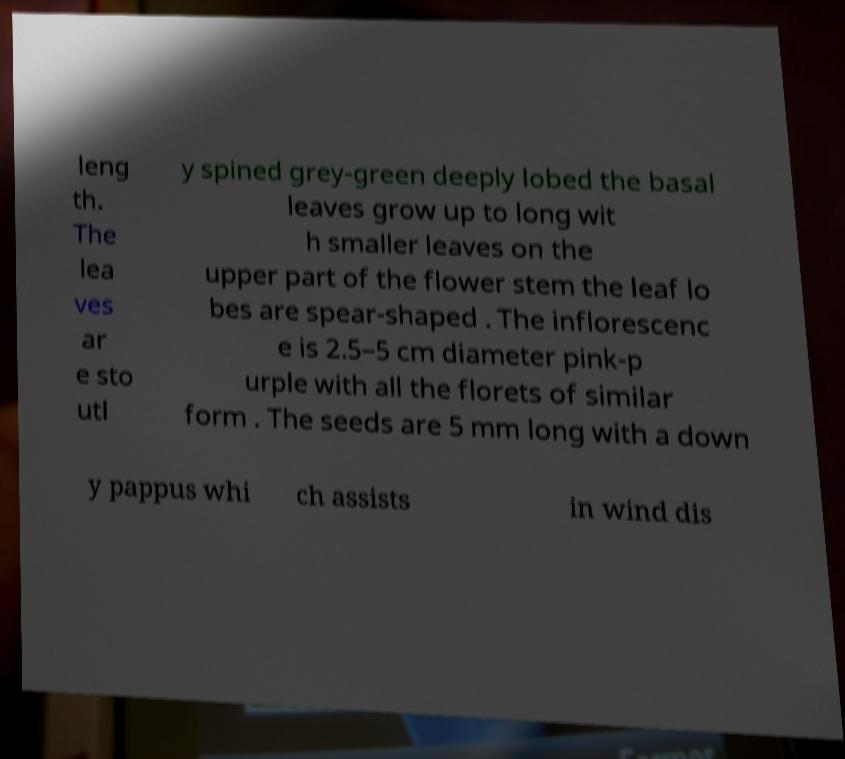There's text embedded in this image that I need extracted. Can you transcribe it verbatim? leng th. The lea ves ar e sto utl y spined grey-green deeply lobed the basal leaves grow up to long wit h smaller leaves on the upper part of the flower stem the leaf lo bes are spear-shaped . The inflorescenc e is 2.5–5 cm diameter pink-p urple with all the florets of similar form . The seeds are 5 mm long with a down y pappus whi ch assists in wind dis 